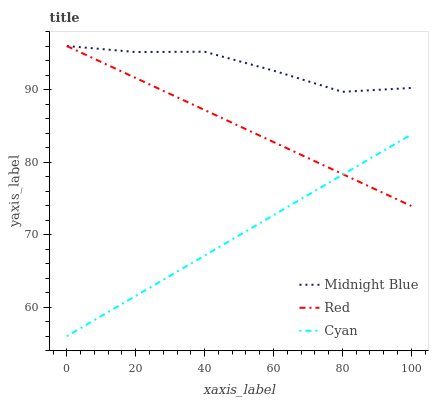Does Cyan have the minimum area under the curve?
Answer yes or no. Yes. Does Midnight Blue have the maximum area under the curve?
Answer yes or no. Yes. Does Red have the minimum area under the curve?
Answer yes or no. No. Does Red have the maximum area under the curve?
Answer yes or no. No. Is Red the smoothest?
Answer yes or no. Yes. Is Midnight Blue the roughest?
Answer yes or no. Yes. Is Midnight Blue the smoothest?
Answer yes or no. No. Is Red the roughest?
Answer yes or no. No. Does Cyan have the lowest value?
Answer yes or no. Yes. Does Red have the lowest value?
Answer yes or no. No. Does Red have the highest value?
Answer yes or no. Yes. Is Cyan less than Midnight Blue?
Answer yes or no. Yes. Is Midnight Blue greater than Cyan?
Answer yes or no. Yes. Does Midnight Blue intersect Red?
Answer yes or no. Yes. Is Midnight Blue less than Red?
Answer yes or no. No. Is Midnight Blue greater than Red?
Answer yes or no. No. Does Cyan intersect Midnight Blue?
Answer yes or no. No. 